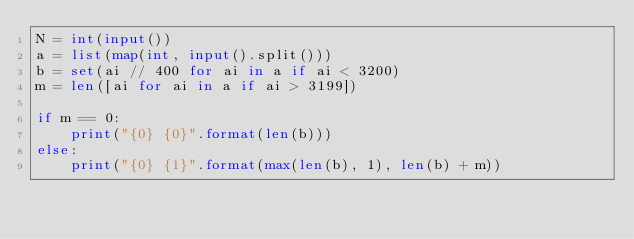Convert code to text. <code><loc_0><loc_0><loc_500><loc_500><_Python_>N = int(input())
a = list(map(int, input().split()))
b = set(ai // 400 for ai in a if ai < 3200)
m = len([ai for ai in a if ai > 3199])

if m == 0:
    print("{0} {0}".format(len(b)))
else:
    print("{0} {1}".format(max(len(b), 1), len(b) + m))
</code> 